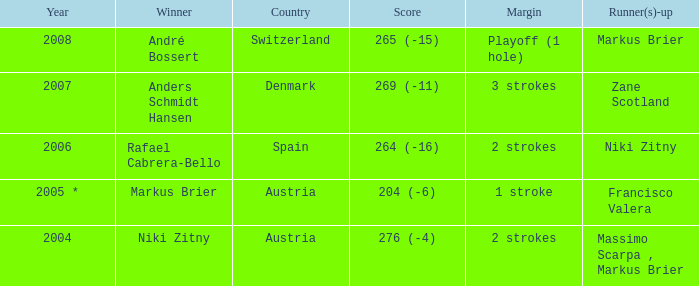What was the score in the year 2004? 276 (-4). Would you mind parsing the complete table? {'header': ['Year', 'Winner', 'Country', 'Score', 'Margin', 'Runner(s)-up'], 'rows': [['2008', 'André Bossert', 'Switzerland', '265 (-15)', 'Playoff (1 hole)', 'Markus Brier'], ['2007', 'Anders Schmidt Hansen', 'Denmark', '269 (-11)', '3 strokes', 'Zane Scotland'], ['2006', 'Rafael Cabrera-Bello', 'Spain', '264 (-16)', '2 strokes', 'Niki Zitny'], ['2005 *', 'Markus Brier', 'Austria', '204 (-6)', '1 stroke', 'Francisco Valera'], ['2004', 'Niki Zitny', 'Austria', '276 (-4)', '2 strokes', 'Massimo Scarpa , Markus Brier']]} 